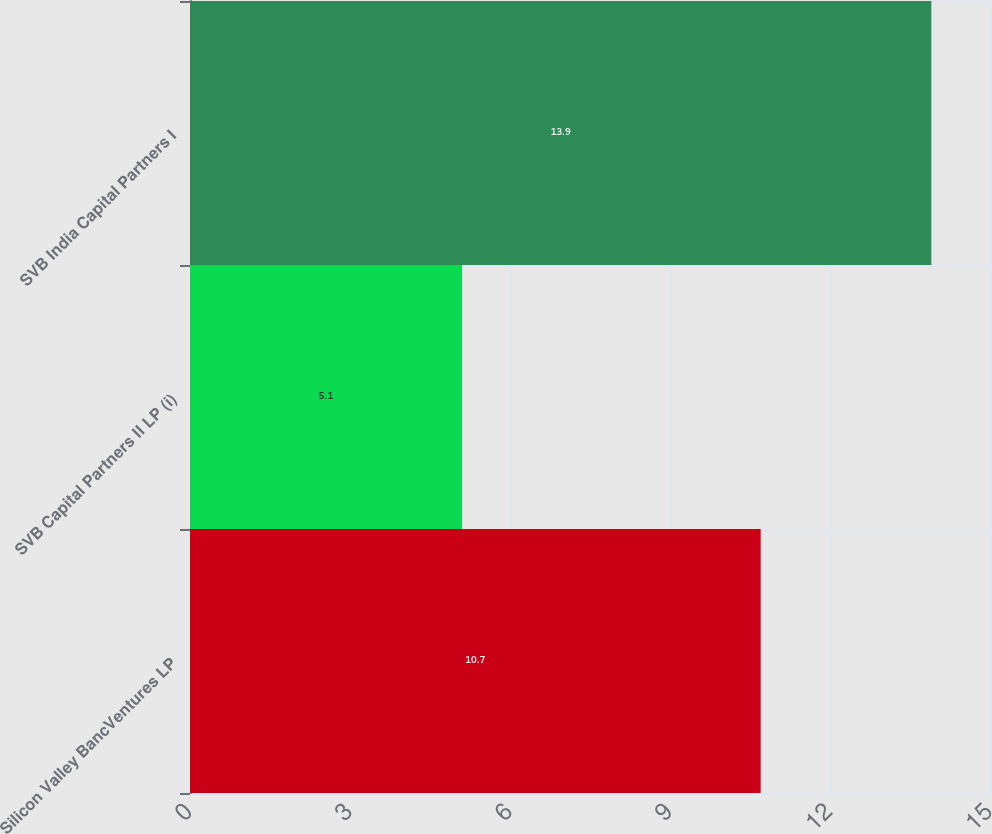Convert chart. <chart><loc_0><loc_0><loc_500><loc_500><bar_chart><fcel>Silicon Valley BancVentures LP<fcel>SVB Capital Partners II LP (i)<fcel>SVB India Capital Partners I<nl><fcel>10.7<fcel>5.1<fcel>13.9<nl></chart> 